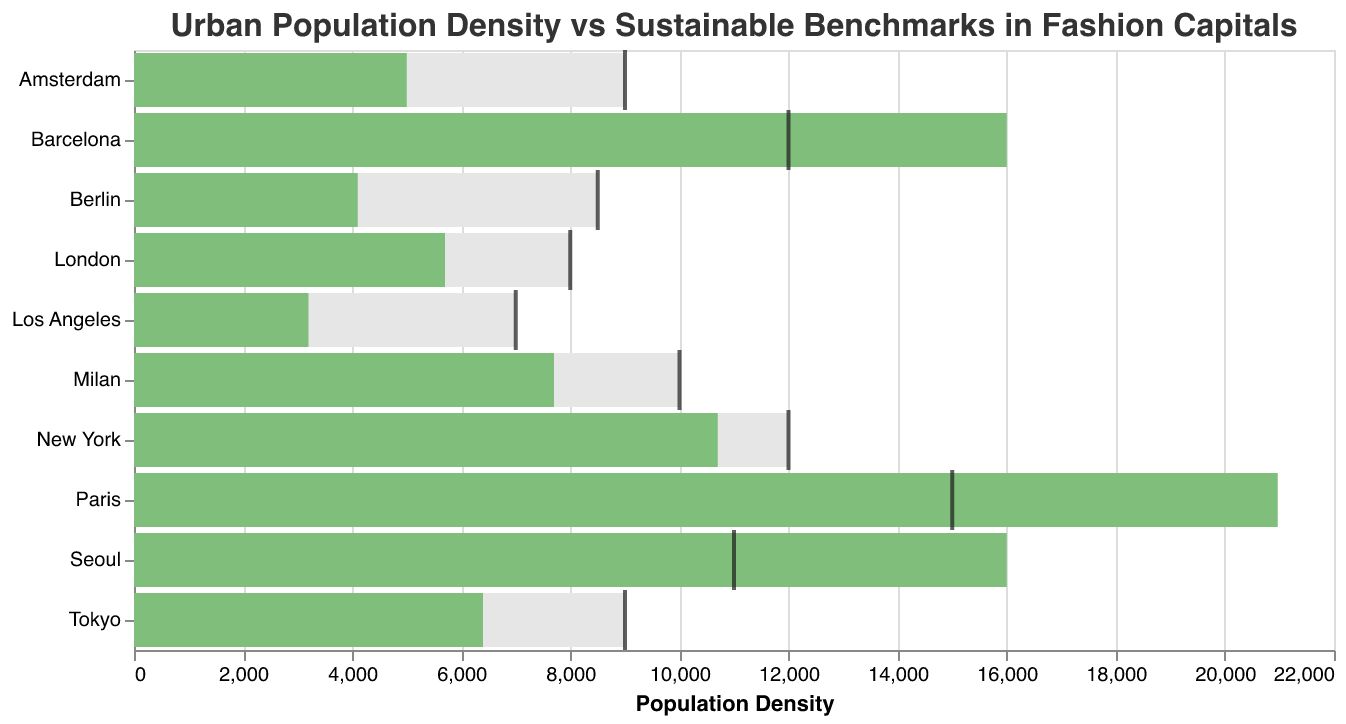How many cities have a population density above their sustainable benchmark? Count the cities where the population density bar is longer than the sustainable benchmark (which is represented by a tick mark). These cities are Paris, Barcelona, and Seoul.
Answer: 3 Which city has the highest population density? Look at the length of the green bar (Population Density). Paris has the longest bar indicating the highest population density.
Answer: Paris How much greater is Paris's population density compared to its sustainable benchmark? Find the population density for Paris (20970) and its sustainable benchmark (15000). Subtract the two values: 20970 - 15000 = 5970.
Answer: 5970 Which city has the lowest population density relative to its sustainable benchmark? Look at the visual difference between the green bar (Population Density) and the tick mark (Sustainable Benchmark). Los Angeles has the biggest gap below the benchmark.
Answer: Los Angeles What is the average sustainable benchmark for all cities? Sum all the sustainable benchmarks and then divide by the number of cities (10). (15000 + 12000 + 10000 + 8000 + 9000 + 7000 + 8500 + 12000 + 9000 + 11000) / 10 = 10150.
Answer: 10150 Which city has the smallest difference between its population density and the sustainable benchmark? Find the city where the green bar is closest to its corresponding tick mark. New York City's density (10700) is just 1300 less than its benchmark (12000).
Answer: New York Which cities have a population density that is below their sustainable benchmark? Observe the green bars that are shorter than their corresponding tick marks. The cities are New York, Milan, London, Tokyo, Los Angeles, Berlin, and Amsterdam.
Answer: 7 Which city has the highest fashion capital rating and how does its population density compare to the sustainable benchmark? Identify the city with the highest fashion capital rating (Paris with a rating of 95) and compare its population density (20970) to its sustainable benchmark (15000). Paris significantly exceeds its benchmark by 5970.
Answer: Paris, exceeds by 5970 Calculate the sum of population densities of all cities where density exceeds the benchmark? Sum the population densities of Paris, Barcelona, and Seoul. 20970 + 16000 + 16000 = 52970.
Answer: 52970 Which cities have a fashion capital rating above 80, and how do their population densities compare to their sustainable benchmarks? First, filter the cities with a fashion capital rating above 80 (Paris, New York, Milan, London, Tokyo, and Los Angeles). Then compare their population densities to the benchmarks:
- Paris: Exceeds by 5970
- New York: Below by 1300
- Milan: Below by 2300
- London: Below by 2300
- Tokyo: Below by 2600
- Los Angeles: Below by 3800
Answer: Paris exceeds; New York, Milan, London, Tokyo, and Los Angeles below 